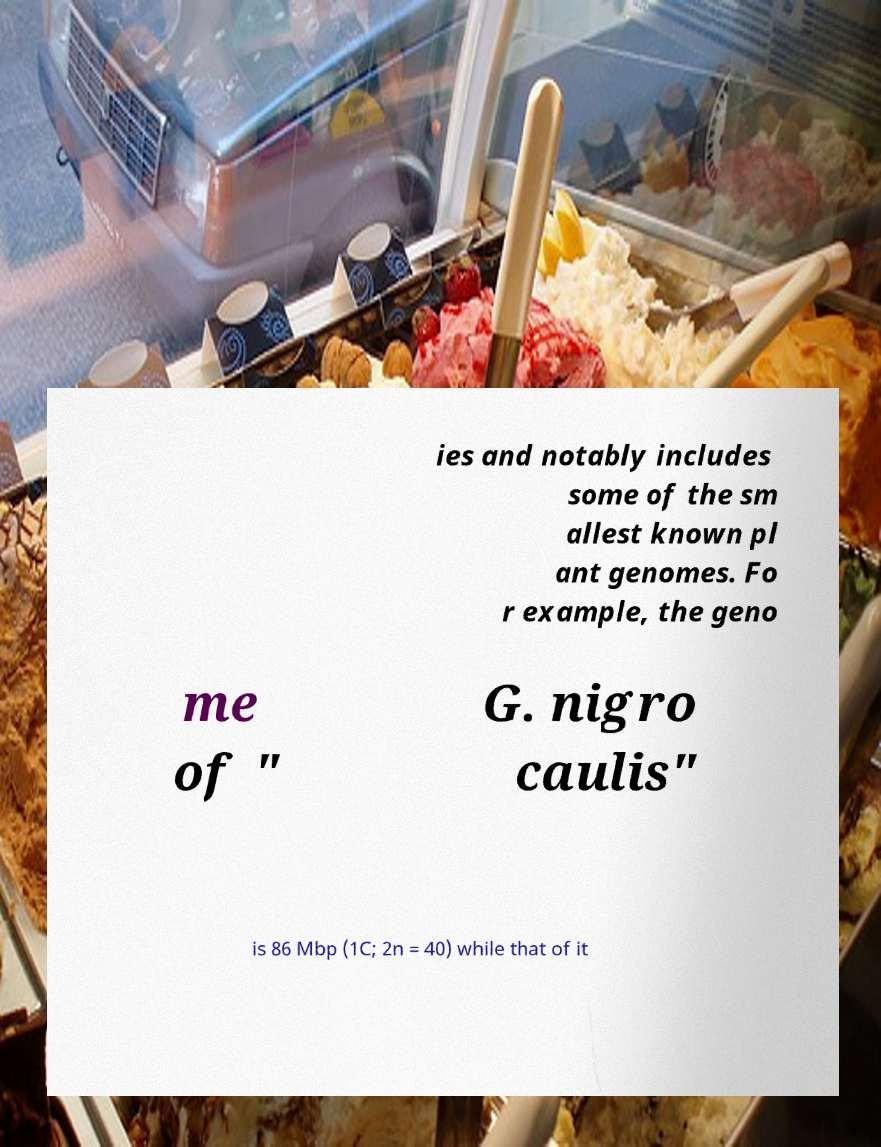What messages or text are displayed in this image? I need them in a readable, typed format. ies and notably includes some of the sm allest known pl ant genomes. Fo r example, the geno me of " G. nigro caulis" is 86 Mbp (1C; 2n = 40) while that of it 